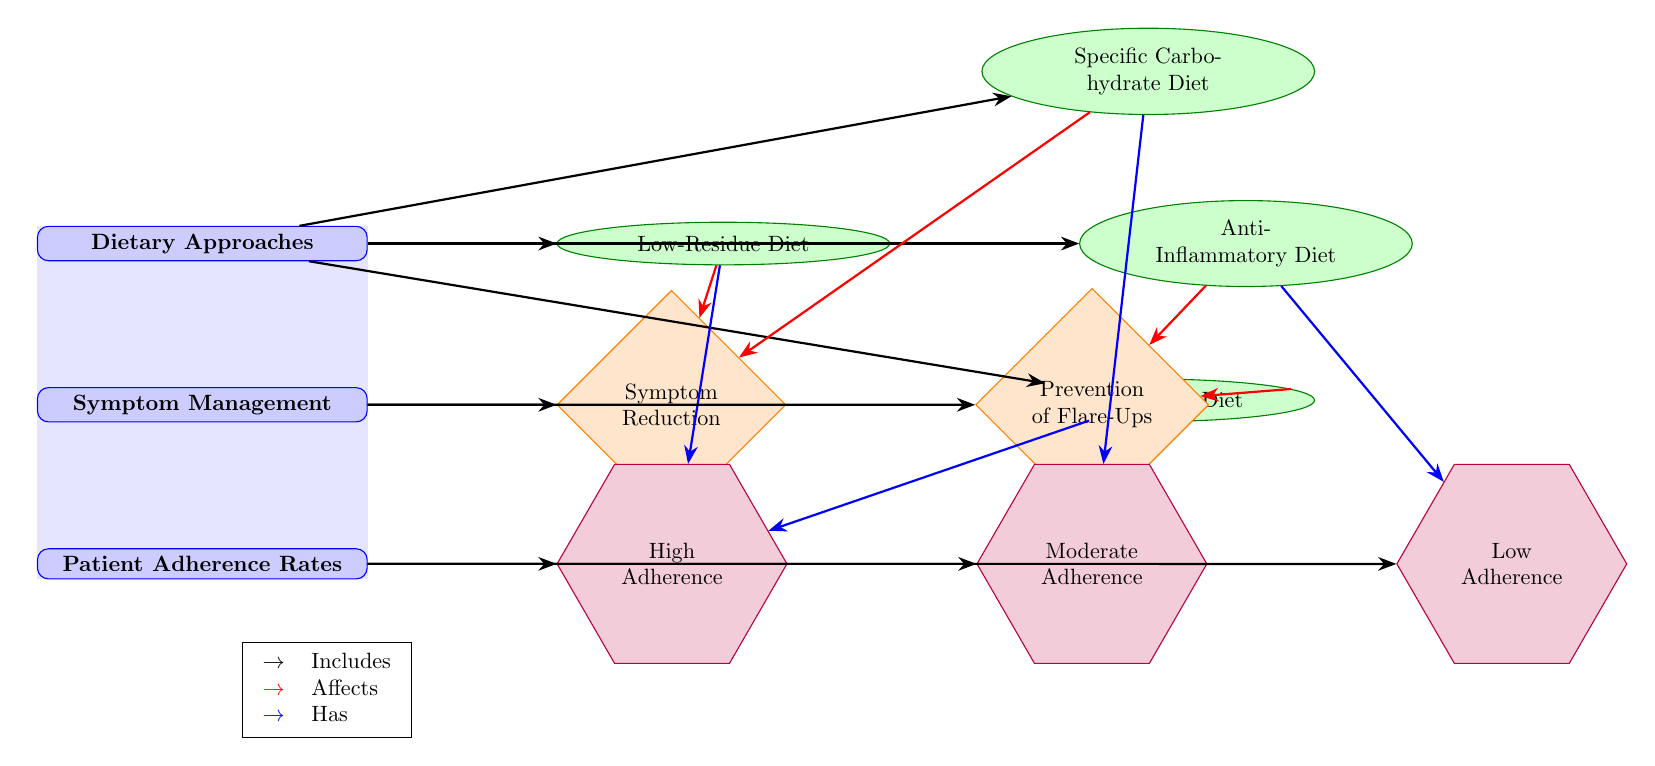What are the dietary approaches listed in the diagram? The diagram mentions four dietary approaches: Low-Residue Diet, Specific Carbohydrate Diet, Mediterranean Diet, and Anti-Inflammatory Diet.
Answer: Low-Residue Diet, Specific Carbohydrate Diet, Mediterranean Diet, Anti-Inflammatory Diet Which dietary approach is indicated to have high adherence rates? The diagram shows that the Mediterranean Diet is connected with high adherence rates.
Answer: Mediterranean Diet How many types of symptom management effects are illustrated? There are two types of symptom management effects in the diagram: Symptom Reduction and Prevention of Flare-Ups.
Answer: 2 What is the effect of the Low-Residue Diet on symptom management? The diagram connects the Low-Residue Diet to the effect of Symptom Reduction, indicating that it helps reduce symptoms.
Answer: Symptom Reduction Which dietary approach has low adherence rates according to the diagram? The diagram shows that the Anti-Inflammatory Diet is associated with low adherence rates.
Answer: Anti-Inflammatory Diet What is the relationship between adherence and the Specific Carbohydrate Diet? The diagram indicates that the Specific Carbohydrate Diet has moderate adherence rates, meaning not all patients find it easy to maintain.
Answer: Moderate Adherence Which symptom management effect does the Mediterranean Diet primarily influence? According to the diagram, the Mediterranean Diet leads to Symptom Reduction and is linked to high adherence, indicating its effectiveness in managing symptoms.
Answer: Symptom Reduction How many connections does the Low-Residue Diet have in relation to symptom management? The Low-Residue Diet has two connections: one leading to Symptom Reduction and the other leading to high adherence rates.
Answer: 2 